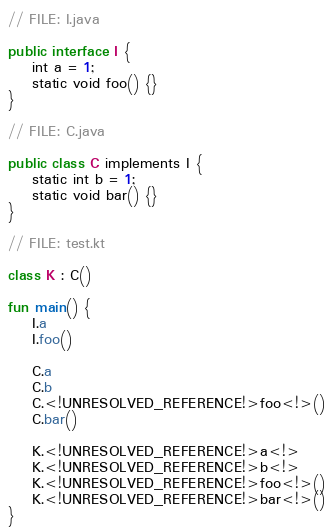Convert code to text. <code><loc_0><loc_0><loc_500><loc_500><_Kotlin_>// FILE: I.java

public interface I {
    int a = 1;
    static void foo() {}
}

// FILE: C.java

public class C implements I {
    static int b = 1;
    static void bar() {}
}

// FILE: test.kt

class K : C()

fun main() {
    I.a
    I.foo()

    C.a
    C.b
    C.<!UNRESOLVED_REFERENCE!>foo<!>()
    C.bar()

    K.<!UNRESOLVED_REFERENCE!>a<!>
    K.<!UNRESOLVED_REFERENCE!>b<!>
    K.<!UNRESOLVED_REFERENCE!>foo<!>()
    K.<!UNRESOLVED_REFERENCE!>bar<!>()
}
</code> 